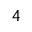<formula> <loc_0><loc_0><loc_500><loc_500>_ { 4 }</formula> 